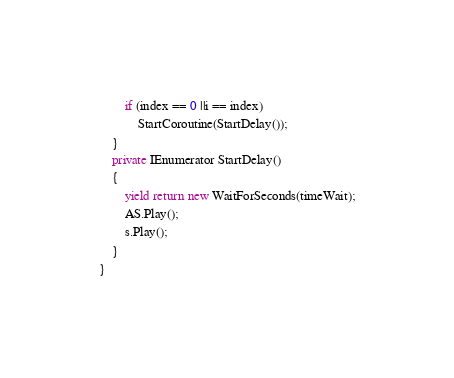<code> <loc_0><loc_0><loc_500><loc_500><_C#_>        if (index == 0 ||i == index)
            StartCoroutine(StartDelay());
    }
    private IEnumerator StartDelay()
    {
        yield return new WaitForSeconds(timeWait);
        AS.Play();
        s.Play();
    }
}
</code> 